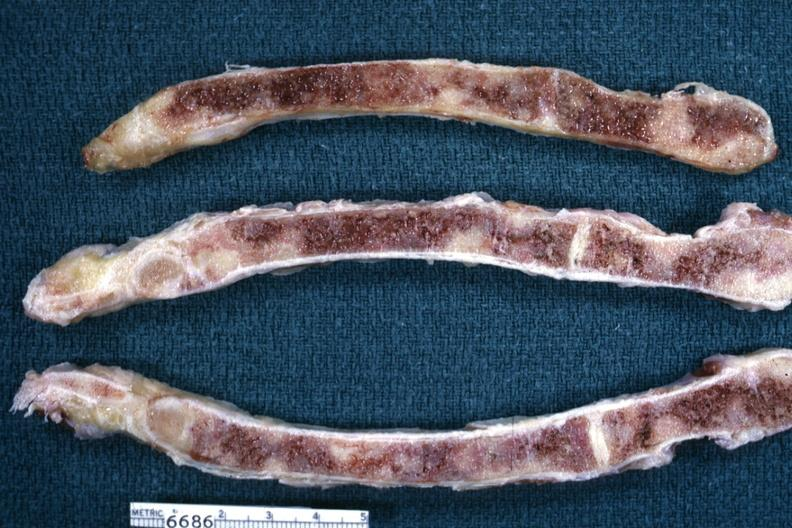does tuberculosis show sections of sternum with metastatic lesions from breast?
Answer the question using a single word or phrase. No 